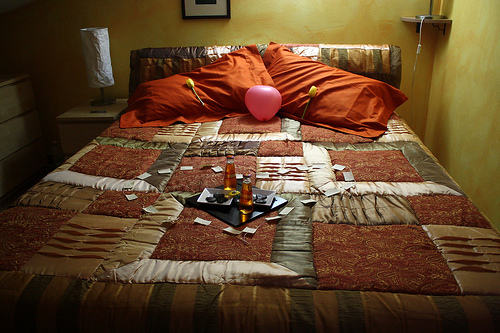<image>
Is there a balloon next to the bottle? No. The balloon is not positioned next to the bottle. They are located in different areas of the scene. Is there a photo behind the bottle? Yes. From this viewpoint, the photo is positioned behind the bottle, with the bottle partially or fully occluding the photo. 